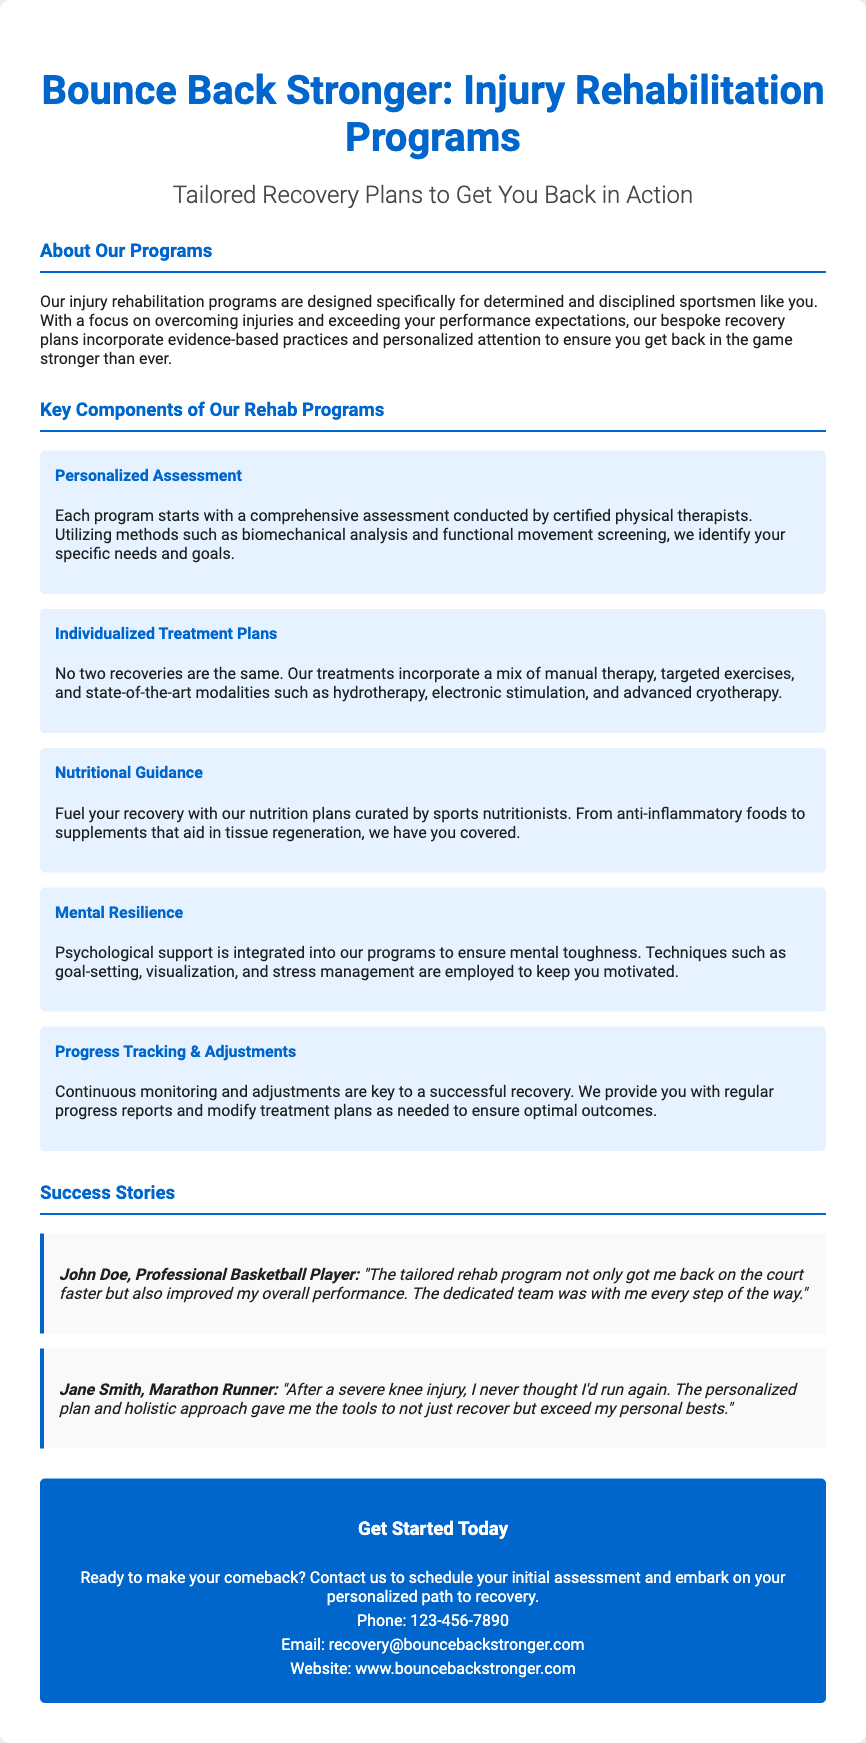What is the title of the flyer? The title of the flyer is prominently displayed at the top, indicating the main focus of the document.
Answer: Bounce Back Stronger: Injury Rehabilitation Programs Who are the programs designed for? The document specifies that the programs cater to a specific group of individuals, indicating the target audience.
Answer: Determined and disciplined sportsmen What is the phone number provided for contact? The contact section includes a clear and direct method for potential clients to reach out for more information.
Answer: 123-456-7890 How is progress tracked according to the flyer? The flyer describes an important aspect of the rehabilitation process, highlighting how outcomes are monitored.
Answer: Progress Tracking & Adjustments What type of therapy is mentioned in the Individualized Treatment Plans? This component lists various methods utilized in the rehabilitation programs.
Answer: Manual therapy What support is included to enhance mental resilience? The flyer outlines a critical element of the program that focuses on emotional and mental fortitude, which is essential for athletes.
Answer: Psychological support What is one success story mentioned in the flyer? The document includes testimonials that showcase the effectiveness of the rehabilitation programs through personal experiences.
Answer: John Doe, Professional Basketball Player What does the nutritional guidance focus on? This component highlights the nutritional aspect of the recovery process tailored for athletes.
Answer: Anti-inflammatory foods 